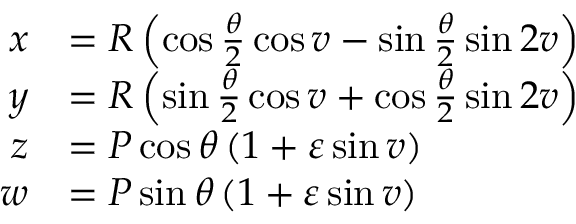<formula> <loc_0><loc_0><loc_500><loc_500>{ \begin{array} { r l } { x } & { = R \left ( \cos { \frac { \theta } { 2 } } \cos v - \sin { \frac { \theta } { 2 } } \sin 2 v \right ) } \\ { y } & { = R \left ( \sin { \frac { \theta } { 2 } } \cos v + \cos { \frac { \theta } { 2 } } \sin 2 v \right ) } \\ { z } & { = P \cos \theta \left ( 1 + \varepsilon \sin v \right ) } \\ { w } & { = P \sin \theta \left ( 1 + { \varepsilon } \sin v \right ) } \end{array} }</formula> 